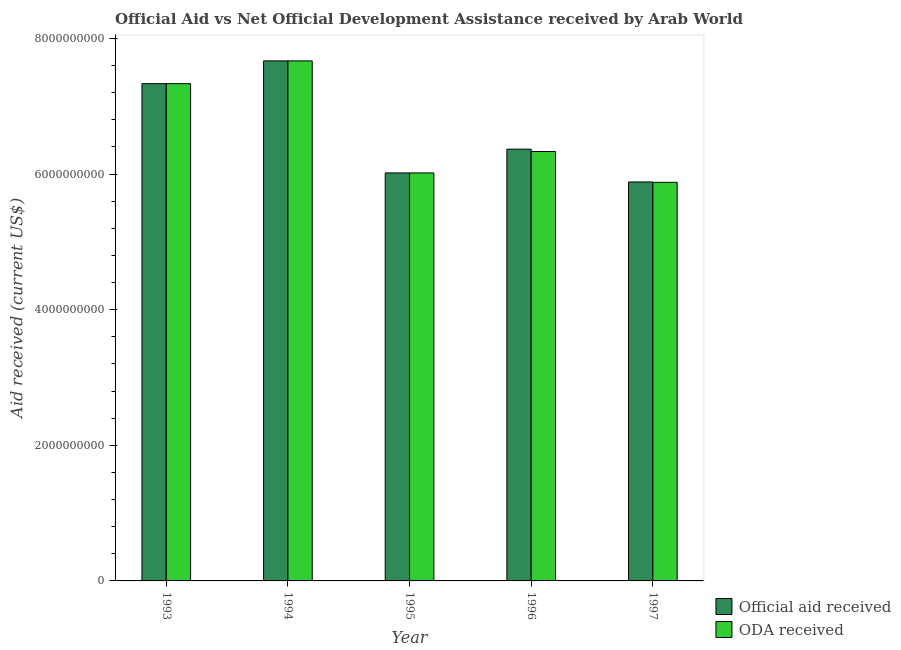Are the number of bars per tick equal to the number of legend labels?
Offer a very short reply. Yes. Are the number of bars on each tick of the X-axis equal?
Make the answer very short. Yes. How many bars are there on the 4th tick from the left?
Offer a very short reply. 2. In how many cases, is the number of bars for a given year not equal to the number of legend labels?
Ensure brevity in your answer.  0. What is the oda received in 1994?
Your answer should be compact. 7.67e+09. Across all years, what is the maximum oda received?
Offer a terse response. 7.67e+09. Across all years, what is the minimum official aid received?
Offer a very short reply. 5.88e+09. In which year was the oda received maximum?
Give a very brief answer. 1994. What is the total oda received in the graph?
Make the answer very short. 3.32e+1. What is the difference between the oda received in 1994 and that in 1995?
Keep it short and to the point. 1.65e+09. What is the difference between the oda received in 1994 and the official aid received in 1995?
Make the answer very short. 1.65e+09. What is the average official aid received per year?
Offer a very short reply. 6.65e+09. In how many years, is the oda received greater than 5600000000 US$?
Offer a very short reply. 5. What is the ratio of the oda received in 1993 to that in 1996?
Provide a short and direct response. 1.16. What is the difference between the highest and the second highest official aid received?
Offer a very short reply. 3.36e+08. What is the difference between the highest and the lowest oda received?
Offer a terse response. 1.79e+09. In how many years, is the official aid received greater than the average official aid received taken over all years?
Your response must be concise. 2. What does the 1st bar from the left in 1994 represents?
Your response must be concise. Official aid received. What does the 1st bar from the right in 1996 represents?
Your answer should be very brief. ODA received. How many bars are there?
Your response must be concise. 10. Are all the bars in the graph horizontal?
Make the answer very short. No. How many years are there in the graph?
Make the answer very short. 5. What is the difference between two consecutive major ticks on the Y-axis?
Your response must be concise. 2.00e+09. Does the graph contain any zero values?
Offer a terse response. No. Does the graph contain grids?
Offer a very short reply. No. How are the legend labels stacked?
Offer a very short reply. Vertical. What is the title of the graph?
Give a very brief answer. Official Aid vs Net Official Development Assistance received by Arab World . Does "Female" appear as one of the legend labels in the graph?
Your answer should be compact. No. What is the label or title of the Y-axis?
Offer a terse response. Aid received (current US$). What is the Aid received (current US$) in Official aid received in 1993?
Give a very brief answer. 7.33e+09. What is the Aid received (current US$) in ODA received in 1993?
Your response must be concise. 7.33e+09. What is the Aid received (current US$) in Official aid received in 1994?
Provide a short and direct response. 7.67e+09. What is the Aid received (current US$) of ODA received in 1994?
Provide a short and direct response. 7.67e+09. What is the Aid received (current US$) of Official aid received in 1995?
Your response must be concise. 6.02e+09. What is the Aid received (current US$) in ODA received in 1995?
Your response must be concise. 6.02e+09. What is the Aid received (current US$) in Official aid received in 1996?
Make the answer very short. 6.37e+09. What is the Aid received (current US$) of ODA received in 1996?
Make the answer very short. 6.33e+09. What is the Aid received (current US$) of Official aid received in 1997?
Your response must be concise. 5.88e+09. What is the Aid received (current US$) in ODA received in 1997?
Offer a terse response. 5.88e+09. Across all years, what is the maximum Aid received (current US$) of Official aid received?
Your response must be concise. 7.67e+09. Across all years, what is the maximum Aid received (current US$) in ODA received?
Offer a terse response. 7.67e+09. Across all years, what is the minimum Aid received (current US$) in Official aid received?
Offer a terse response. 5.88e+09. Across all years, what is the minimum Aid received (current US$) in ODA received?
Offer a very short reply. 5.88e+09. What is the total Aid received (current US$) in Official aid received in the graph?
Offer a very short reply. 3.33e+1. What is the total Aid received (current US$) of ODA received in the graph?
Your answer should be very brief. 3.32e+1. What is the difference between the Aid received (current US$) of Official aid received in 1993 and that in 1994?
Provide a succinct answer. -3.36e+08. What is the difference between the Aid received (current US$) in ODA received in 1993 and that in 1994?
Your answer should be very brief. -3.36e+08. What is the difference between the Aid received (current US$) in Official aid received in 1993 and that in 1995?
Give a very brief answer. 1.32e+09. What is the difference between the Aid received (current US$) of ODA received in 1993 and that in 1995?
Offer a terse response. 1.32e+09. What is the difference between the Aid received (current US$) of Official aid received in 1993 and that in 1996?
Your answer should be compact. 9.66e+08. What is the difference between the Aid received (current US$) of ODA received in 1993 and that in 1996?
Your response must be concise. 1.00e+09. What is the difference between the Aid received (current US$) in Official aid received in 1993 and that in 1997?
Make the answer very short. 1.45e+09. What is the difference between the Aid received (current US$) in ODA received in 1993 and that in 1997?
Your answer should be compact. 1.45e+09. What is the difference between the Aid received (current US$) of Official aid received in 1994 and that in 1995?
Offer a very short reply. 1.65e+09. What is the difference between the Aid received (current US$) of ODA received in 1994 and that in 1995?
Provide a short and direct response. 1.65e+09. What is the difference between the Aid received (current US$) of Official aid received in 1994 and that in 1996?
Offer a very short reply. 1.30e+09. What is the difference between the Aid received (current US$) of ODA received in 1994 and that in 1996?
Give a very brief answer. 1.34e+09. What is the difference between the Aid received (current US$) in Official aid received in 1994 and that in 1997?
Your response must be concise. 1.79e+09. What is the difference between the Aid received (current US$) in ODA received in 1994 and that in 1997?
Give a very brief answer. 1.79e+09. What is the difference between the Aid received (current US$) in Official aid received in 1995 and that in 1996?
Your answer should be very brief. -3.51e+08. What is the difference between the Aid received (current US$) in ODA received in 1995 and that in 1996?
Your answer should be compact. -3.16e+08. What is the difference between the Aid received (current US$) of Official aid received in 1995 and that in 1997?
Ensure brevity in your answer.  1.33e+08. What is the difference between the Aid received (current US$) in ODA received in 1995 and that in 1997?
Your answer should be very brief. 1.38e+08. What is the difference between the Aid received (current US$) in Official aid received in 1996 and that in 1997?
Offer a very short reply. 4.84e+08. What is the difference between the Aid received (current US$) of ODA received in 1996 and that in 1997?
Ensure brevity in your answer.  4.55e+08. What is the difference between the Aid received (current US$) of Official aid received in 1993 and the Aid received (current US$) of ODA received in 1994?
Provide a short and direct response. -3.36e+08. What is the difference between the Aid received (current US$) in Official aid received in 1993 and the Aid received (current US$) in ODA received in 1995?
Ensure brevity in your answer.  1.32e+09. What is the difference between the Aid received (current US$) of Official aid received in 1993 and the Aid received (current US$) of ODA received in 1996?
Provide a succinct answer. 1.00e+09. What is the difference between the Aid received (current US$) in Official aid received in 1993 and the Aid received (current US$) in ODA received in 1997?
Your answer should be very brief. 1.45e+09. What is the difference between the Aid received (current US$) of Official aid received in 1994 and the Aid received (current US$) of ODA received in 1995?
Provide a succinct answer. 1.65e+09. What is the difference between the Aid received (current US$) of Official aid received in 1994 and the Aid received (current US$) of ODA received in 1996?
Offer a terse response. 1.34e+09. What is the difference between the Aid received (current US$) in Official aid received in 1994 and the Aid received (current US$) in ODA received in 1997?
Ensure brevity in your answer.  1.79e+09. What is the difference between the Aid received (current US$) in Official aid received in 1995 and the Aid received (current US$) in ODA received in 1996?
Make the answer very short. -3.16e+08. What is the difference between the Aid received (current US$) in Official aid received in 1995 and the Aid received (current US$) in ODA received in 1997?
Give a very brief answer. 1.38e+08. What is the difference between the Aid received (current US$) in Official aid received in 1996 and the Aid received (current US$) in ODA received in 1997?
Give a very brief answer. 4.89e+08. What is the average Aid received (current US$) in Official aid received per year?
Provide a short and direct response. 6.65e+09. What is the average Aid received (current US$) of ODA received per year?
Offer a very short reply. 6.65e+09. In the year 1995, what is the difference between the Aid received (current US$) in Official aid received and Aid received (current US$) in ODA received?
Your answer should be very brief. 0. In the year 1996, what is the difference between the Aid received (current US$) of Official aid received and Aid received (current US$) of ODA received?
Make the answer very short. 3.46e+07. In the year 1997, what is the difference between the Aid received (current US$) of Official aid received and Aid received (current US$) of ODA received?
Provide a short and direct response. 5.08e+06. What is the ratio of the Aid received (current US$) of Official aid received in 1993 to that in 1994?
Your answer should be compact. 0.96. What is the ratio of the Aid received (current US$) of ODA received in 1993 to that in 1994?
Provide a short and direct response. 0.96. What is the ratio of the Aid received (current US$) in Official aid received in 1993 to that in 1995?
Your answer should be compact. 1.22. What is the ratio of the Aid received (current US$) in ODA received in 1993 to that in 1995?
Provide a succinct answer. 1.22. What is the ratio of the Aid received (current US$) of Official aid received in 1993 to that in 1996?
Your answer should be compact. 1.15. What is the ratio of the Aid received (current US$) of ODA received in 1993 to that in 1996?
Keep it short and to the point. 1.16. What is the ratio of the Aid received (current US$) of Official aid received in 1993 to that in 1997?
Provide a short and direct response. 1.25. What is the ratio of the Aid received (current US$) of ODA received in 1993 to that in 1997?
Make the answer very short. 1.25. What is the ratio of the Aid received (current US$) in Official aid received in 1994 to that in 1995?
Provide a succinct answer. 1.27. What is the ratio of the Aid received (current US$) in ODA received in 1994 to that in 1995?
Give a very brief answer. 1.27. What is the ratio of the Aid received (current US$) of Official aid received in 1994 to that in 1996?
Your response must be concise. 1.2. What is the ratio of the Aid received (current US$) in ODA received in 1994 to that in 1996?
Provide a short and direct response. 1.21. What is the ratio of the Aid received (current US$) of Official aid received in 1994 to that in 1997?
Ensure brevity in your answer.  1.3. What is the ratio of the Aid received (current US$) in ODA received in 1994 to that in 1997?
Provide a succinct answer. 1.3. What is the ratio of the Aid received (current US$) in Official aid received in 1995 to that in 1996?
Offer a terse response. 0.94. What is the ratio of the Aid received (current US$) in ODA received in 1995 to that in 1996?
Make the answer very short. 0.95. What is the ratio of the Aid received (current US$) in Official aid received in 1995 to that in 1997?
Your response must be concise. 1.02. What is the ratio of the Aid received (current US$) in ODA received in 1995 to that in 1997?
Provide a succinct answer. 1.02. What is the ratio of the Aid received (current US$) of Official aid received in 1996 to that in 1997?
Offer a very short reply. 1.08. What is the ratio of the Aid received (current US$) in ODA received in 1996 to that in 1997?
Give a very brief answer. 1.08. What is the difference between the highest and the second highest Aid received (current US$) in Official aid received?
Ensure brevity in your answer.  3.36e+08. What is the difference between the highest and the second highest Aid received (current US$) in ODA received?
Make the answer very short. 3.36e+08. What is the difference between the highest and the lowest Aid received (current US$) of Official aid received?
Make the answer very short. 1.79e+09. What is the difference between the highest and the lowest Aid received (current US$) of ODA received?
Your response must be concise. 1.79e+09. 